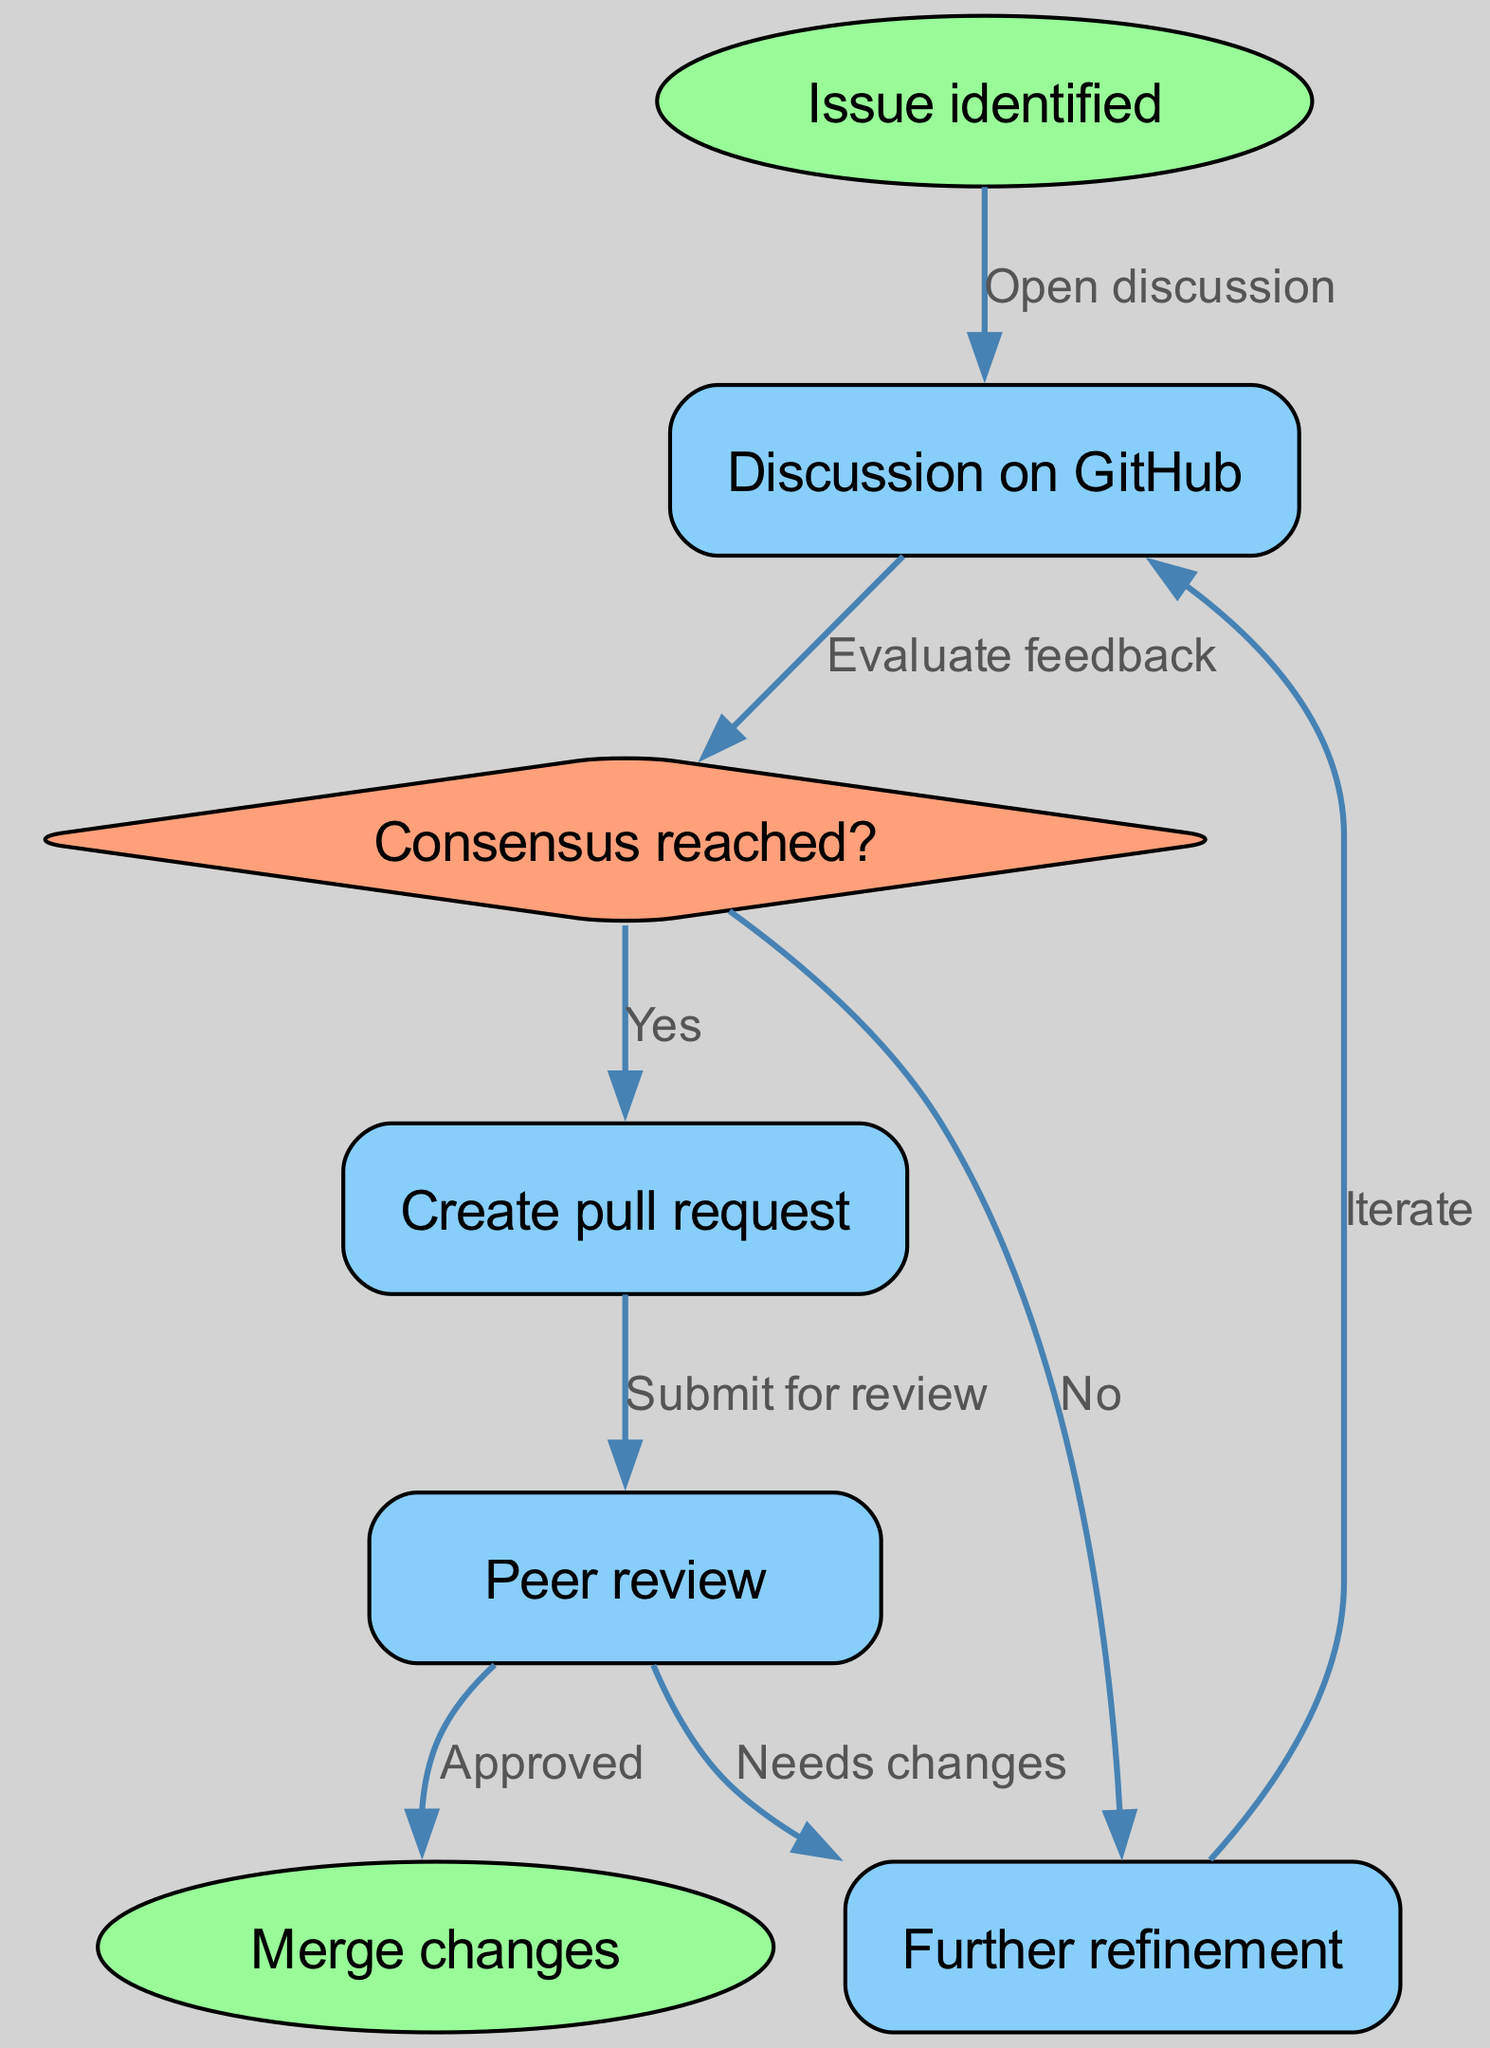What is the starting point of the decision-making process? The initial node in the flow diagram that represents where the process begins is labeled "Issue identified." This is confirmed by identifying the node with ID "1."
Answer: Issue identified How many nodes are present in the diagram? Counting all the unique nodes listed in the diagram, including the starting and ending nodes, we find there are a total of seven nodes that represent different stages in the decision-making process.
Answer: 7 What happens after "Discussion on GitHub"? Following the node "Discussion on GitHub," which is identified as node "2," the flow proceeds to the next decision point where feedback is evaluated, indicated by node "3."
Answer: Evaluate feedback What does the consensus node lead to when the answer is "Yes"? The flow diagram indicates that if the consensus is reached as "Yes," the next step is to create a pull request, which corresponds to node "4." This is confirmed by checking the connection from node "3" to node "4."
Answer: Create pull request What happens if the consensus is "No"? If the consensus at node "3" is determined to be "No," the flow directs to "Further refinement," which is represented by node "7." This can be observed from the edge that connects node "3" to node "7."
Answer: Further refinement How many edges connect the nodes in the diagram? By examining the connections between the nodes, we can count a total of seven edges, showing how each node relates to others in the decision-making process.
Answer: 7 What is the action taken after a pull request is submitted for review? Once the pull request is submitted for review, the next action taken in the process is "Peer review," which corresponds to node "5" of the flow diagram. This can be traced directly from node "4" to node "5."
Answer: Peer review What is the final action in the flow diagram? The last action that occurs in the flow diagram is "Merge changes," which is noted as node "6." This conclusion is reached by following the flow from previous nodes through to the end.
Answer: Merge changes 